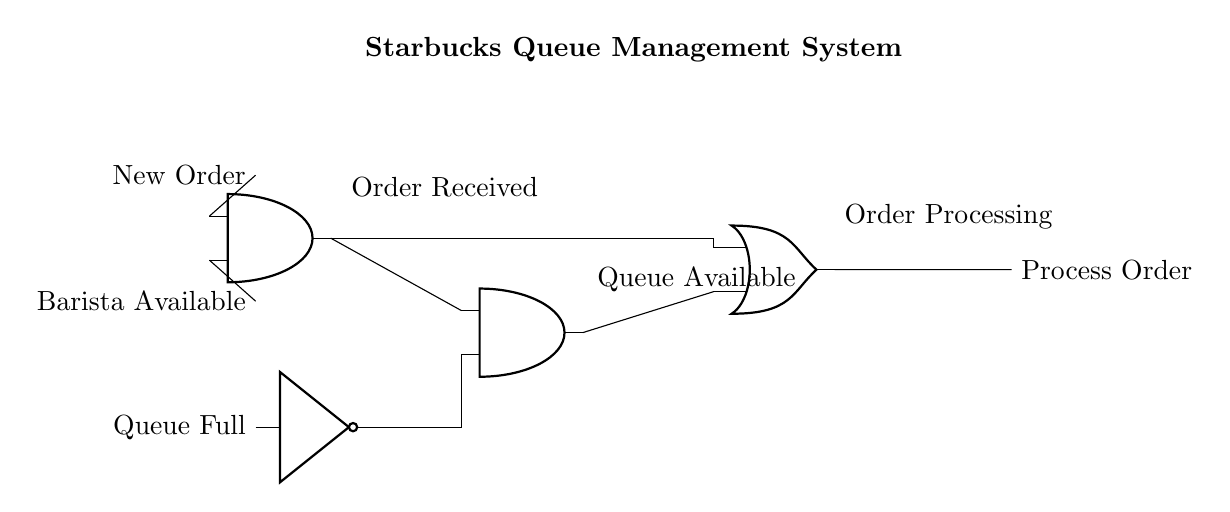What does the first AND gate represent? The first AND gate represents the condition where a new order is received and a barista is available to process the order. This means that both conditions must be true (active) for the gate to output a high signal.
Answer: New Order and Barista Available What does the NOT gate signify in the circuit? The NOT gate signifies the condition of whether the queue is full or not. It outputs a low signal when the queue is full (meaning no new orders can be processed), effectively inverting the input signal.
Answer: Inverted Queue Status How many inputs does the second AND gate have? The second AND gate has two inputs: one input from the first AND gate and one input from the NOT gate. Both conditions must be satisfied for the output to be high.
Answer: Two inputs What conditions are needed for the final output to happen? For the final output to process the order, either the first AND gate must output a high signal along with a queue that's not full (from the NOT gate), or simply a new order must be received while the queue is still available.
Answer: New Order and Queue Availability What type of logic does the final OR gate represent? The final OR gate represents a logical OR condition, meaning that if either of its inputs is true (high), the output will also be true, allowing the order to be processed.
Answer: OR Condition How does this circuit optimize service at Starbucks? The circuit optimizes service by ensuring that orders are only processed when there is capacity (queue not full) and the barista is available, preventing overloading and ensuring efficient service.
Answer: Efficient Service Management 